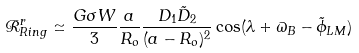<formula> <loc_0><loc_0><loc_500><loc_500>\mathcal { R } ^ { r } _ { R i n g } \simeq \frac { G \sigma W } { 3 } \frac { a } { R _ { o } } \frac { D _ { 1 } \tilde { D } _ { 2 } } { ( a - R _ { o } ) ^ { 2 } } \cos ( \lambda + \varpi _ { B } - \tilde { \phi } _ { L M } )</formula> 